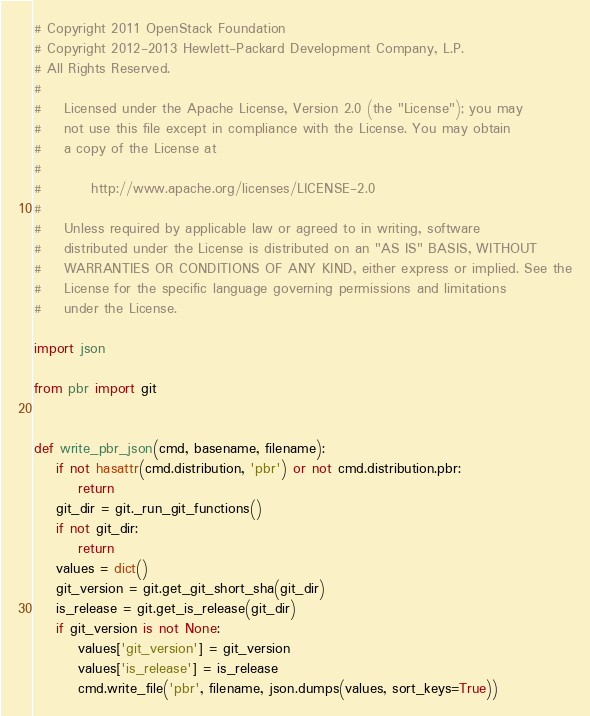Convert code to text. <code><loc_0><loc_0><loc_500><loc_500><_Python_># Copyright 2011 OpenStack Foundation
# Copyright 2012-2013 Hewlett-Packard Development Company, L.P.
# All Rights Reserved.
#
#    Licensed under the Apache License, Version 2.0 (the "License"); you may
#    not use this file except in compliance with the License. You may obtain
#    a copy of the License at
#
#         http://www.apache.org/licenses/LICENSE-2.0
#
#    Unless required by applicable law or agreed to in writing, software
#    distributed under the License is distributed on an "AS IS" BASIS, WITHOUT
#    WARRANTIES OR CONDITIONS OF ANY KIND, either express or implied. See the
#    License for the specific language governing permissions and limitations
#    under the License.

import json

from pbr import git


def write_pbr_json(cmd, basename, filename):
    if not hasattr(cmd.distribution, 'pbr') or not cmd.distribution.pbr:
        return
    git_dir = git._run_git_functions()
    if not git_dir:
        return
    values = dict()
    git_version = git.get_git_short_sha(git_dir)
    is_release = git.get_is_release(git_dir)
    if git_version is not None:
        values['git_version'] = git_version
        values['is_release'] = is_release
        cmd.write_file('pbr', filename, json.dumps(values, sort_keys=True))
</code> 